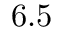<formula> <loc_0><loc_0><loc_500><loc_500>6 . 5</formula> 